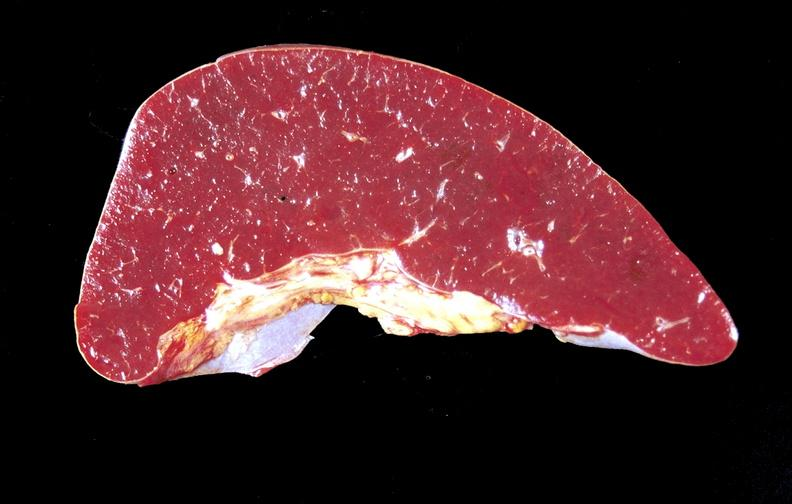does this image show amyloid, spleen?
Answer the question using a single word or phrase. Yes 